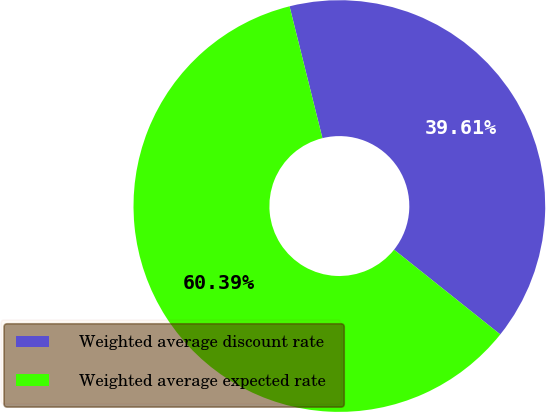Convert chart. <chart><loc_0><loc_0><loc_500><loc_500><pie_chart><fcel>Weighted average discount rate<fcel>Weighted average expected rate<nl><fcel>39.61%<fcel>60.39%<nl></chart> 